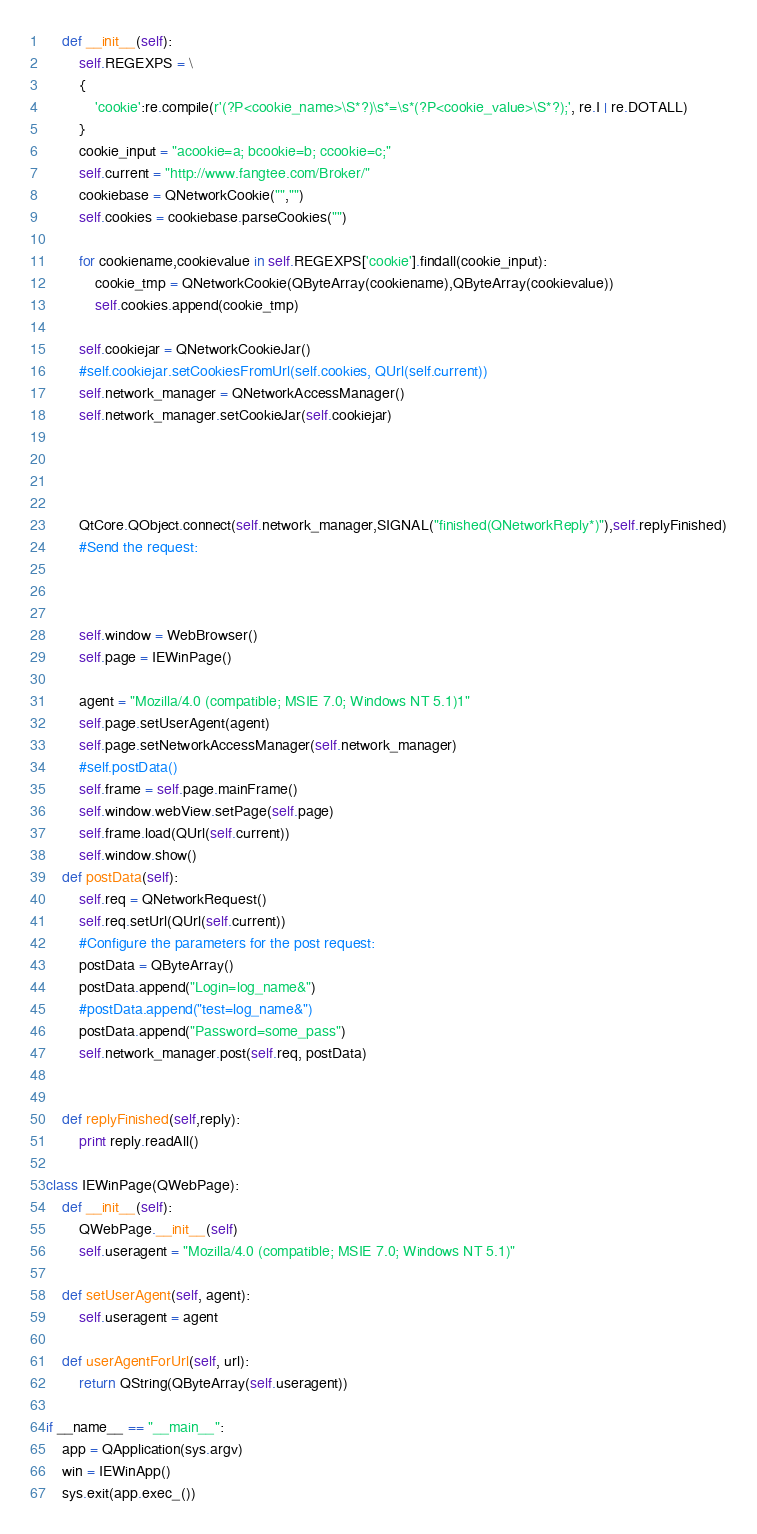Convert code to text. <code><loc_0><loc_0><loc_500><loc_500><_Python_>    def __init__(self):
        self.REGEXPS = \
        {
            'cookie':re.compile(r'(?P<cookie_name>\S*?)\s*=\s*(?P<cookie_value>\S*?);', re.I | re.DOTALL)
        }
        cookie_input = "acookie=a; bcookie=b; ccookie=c;"
        self.current = "http://www.fangtee.com/Broker/"
        cookiebase = QNetworkCookie("","")
        self.cookies = cookiebase.parseCookies("")
        
        for cookiename,cookievalue in self.REGEXPS['cookie'].findall(cookie_input):
            cookie_tmp = QNetworkCookie(QByteArray(cookiename),QByteArray(cookievalue))
            self.cookies.append(cookie_tmp)
        
        self.cookiejar = QNetworkCookieJar()
        #self.cookiejar.setCookiesFromUrl(self.cookies, QUrl(self.current))
        self.network_manager = QNetworkAccessManager()
        self.network_manager.setCookieJar(self.cookiejar)
        
        
        
        
        QtCore.QObject.connect(self.network_manager,SIGNAL("finished(QNetworkReply*)"),self.replyFinished)
        #Send the request:
        
        
        
        self.window = WebBrowser()
        self.page = IEWinPage()
        
        agent = "Mozilla/4.0 (compatible; MSIE 7.0; Windows NT 5.1)1"
        self.page.setUserAgent(agent)
        self.page.setNetworkAccessManager(self.network_manager)   
        #self.postData()     
        self.frame = self.page.mainFrame()
        self.window.webView.setPage(self.page)
        self.frame.load(QUrl(self.current))
        self.window.show()
    def postData(self):
        self.req = QNetworkRequest()
        self.req.setUrl(QUrl(self.current))
        #Configure the parameters for the post request:
        postData = QByteArray()
        postData.append("Login=log_name&")
        #postData.append("test=log_name&")
        postData.append("Password=some_pass")
        self.network_manager.post(self.req, postData)
        
        
    def replyFinished(self,reply):
        print reply.readAll()
        
class IEWinPage(QWebPage):
    def __init__(self):
        QWebPage.__init__(self)
        self.useragent = "Mozilla/4.0 (compatible; MSIE 7.0; Windows NT 5.1)"
    
    def setUserAgent(self, agent):
        self.useragent = agent
 
    def userAgentForUrl(self, url):
        return QString(QByteArray(self.useragent))
        
if __name__ == "__main__":
    app = QApplication(sys.argv)
    win = IEWinApp()
    sys.exit(app.exec_())</code> 